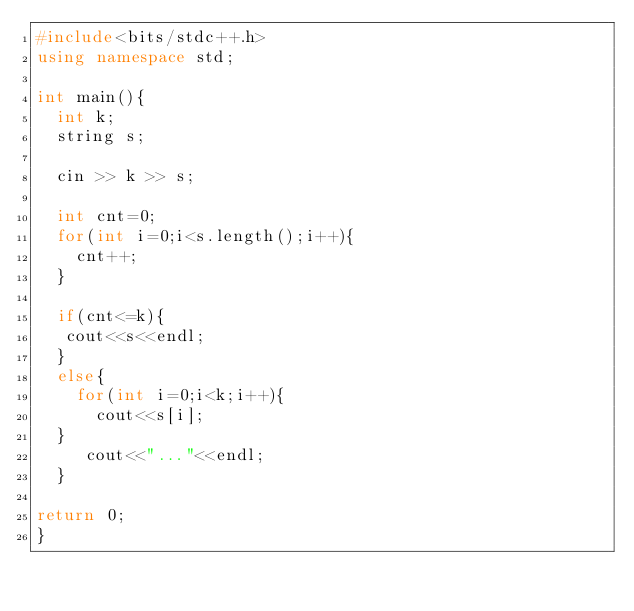Convert code to text. <code><loc_0><loc_0><loc_500><loc_500><_C++_>#include<bits/stdc++.h>
using namespace std;

int main(){
  int k;
  string s;
 
  cin >> k >> s;
  
  int cnt=0;
  for(int i=0;i<s.length();i++){
    cnt++;
  }

  if(cnt<=k){
   cout<<s<<endl;
  }
  else{
    for(int i=0;i<k;i++){
      cout<<s[i];
  }
     cout<<"..."<<endl;
  }
  
return 0;
}

</code> 